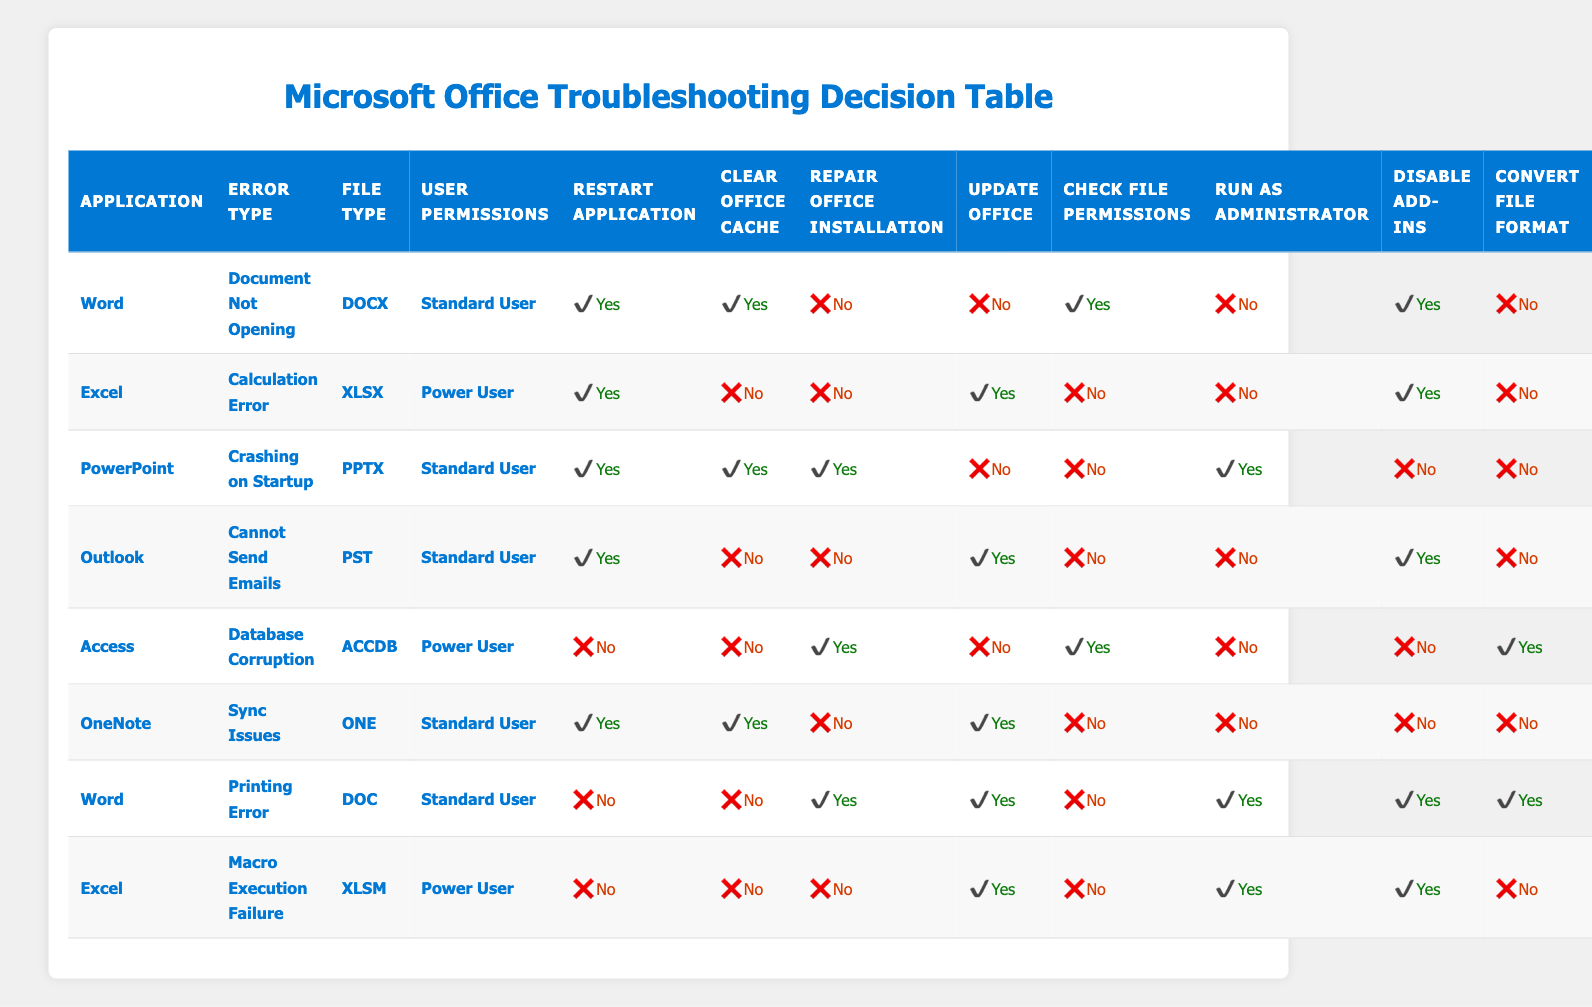What troubleshooting steps should be taken for Word errors when a document is not opening? For the error type "Document Not Opening" in Word, the table indicates that the recommended actions are to restart the application, clear Office cache, check file permissions, and disable add-ins. The table shows 'Yes' for both restarting the application and clearing the cache, while checking file permissions is also suggested. The other actions—repairing, updating, running as administrator, and converting file format—are not recommended.
Answer: Restart application, Clear Office Cache, Check File Permissions, Disable Add-ins Is repairing the Office installation necessary for a Power User experiencing database corruption in Access? According to the table, for the condition of "Database Corruption" in Access for a Power User, the action to repair the Office installation is marked as 'Yes.' This means that repairing the installation is a necessary step to troubleshoot this issue.
Answer: Yes For documents in OneNote, what is the recommended action regarding clearing the Office cache? The table indicates that for "Sync Issues" in OneNote for a Standard User, the action of clearing the Office cache is recommended, as it is marked 'Yes.' This means that users should perform this step when encountering sync issues.
Answer: Yes Which applications require the action "Update Office" when a user faces errors? By examining the table, the relevant actions for error scenarios are as follows: Word (Document Not Opening), Excel (Calculation Error), Outlook (Cannot Send Emails), and OneNote (Sync Issues) all have 'Yes' as a required step for updating Office. Thus, these applications require the update action based on the error type.
Answer: Word, Excel, Outlook, OneNote If a Standard User is facing a printing error in Word, what actions should they take? The conditions for a "Printing Error" in Word identify that a Standard User should not restart the application or clear Office cache, but they should repair the Office installation, update Office, run as administrator, and disable add-ins. The table marks these actions as necessary for resolving the printing issue.
Answer: Repair Office Installation, Update Office, Run as Administrator, Disable Add-ins For a calculation error in Excel reported by a Power User, is running the application as Administrator necessary? The table records that for the "Calculation Error" in Excel with Power User permissions, the action to run the application as Administrator is marked as 'No.' Therefore, this step is not necessary for resolving this specific issue.
Answer: No What is the maximum number of steps recommended for troubleshooting issues in PowerPoint? The maximum number of steps in the table for the error “Crashing on Startup” in PowerPoint for a Standard User includes three possible actions: restarting the application, clearing the Office cache, and repairing the Office installation which are required. The table shows this specific combination indicating a total of three steps required when encountering this situation.
Answer: 3 Is there any error type where checking file permissions is not recommended? By reviewing the table, the rules show that for the error types of "Database Corruption" in Access (Power User) and "Macro Execution Failure" in Excel (Power User), the action "Check File Permissions" is marked as 'No.' Therefore, these two error types do not require checking file permissions.
Answer: Yes Are there any cases where both clearing Office cache and running as Administrator are recommended actions? By inspecting the table, we find the scenario for OneNote "Sync Issues" marked both actions as 'Yes'; hence this specific case requires both clearing Office cache and running the application as Administrator for troubleshooting.
Answer: Yes 